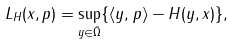Convert formula to latex. <formula><loc_0><loc_0><loc_500><loc_500>L _ { H } ( x , p ) = \sup _ { y \in \bar { \Omega } } \{ \langle y , p \rangle - H ( y , x ) \} ,</formula> 